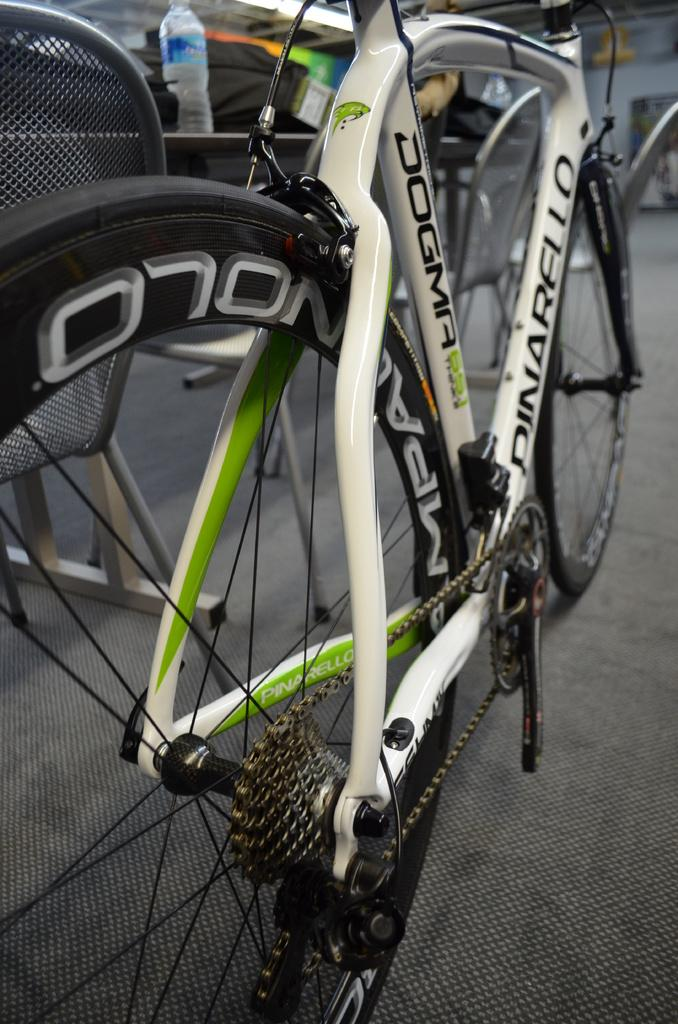What is the main object in the image? There is a bicycle in the image. What other object is present in the image? There is a chair in the image. Where is the chair located in relation to the bicycle? The chair is beside the bicycle. What can be found on a table in the image? There is a bottle of water on a table in the image. Where is the table located in relation to the chair? The table is beside the chair. What type of jellyfish can be seen ringing bells in the image? There are no jellyfish or bells present in the image. What time of day is depicted in the image? The provided facts do not mention the time of day, so it cannot be determined from the image. 